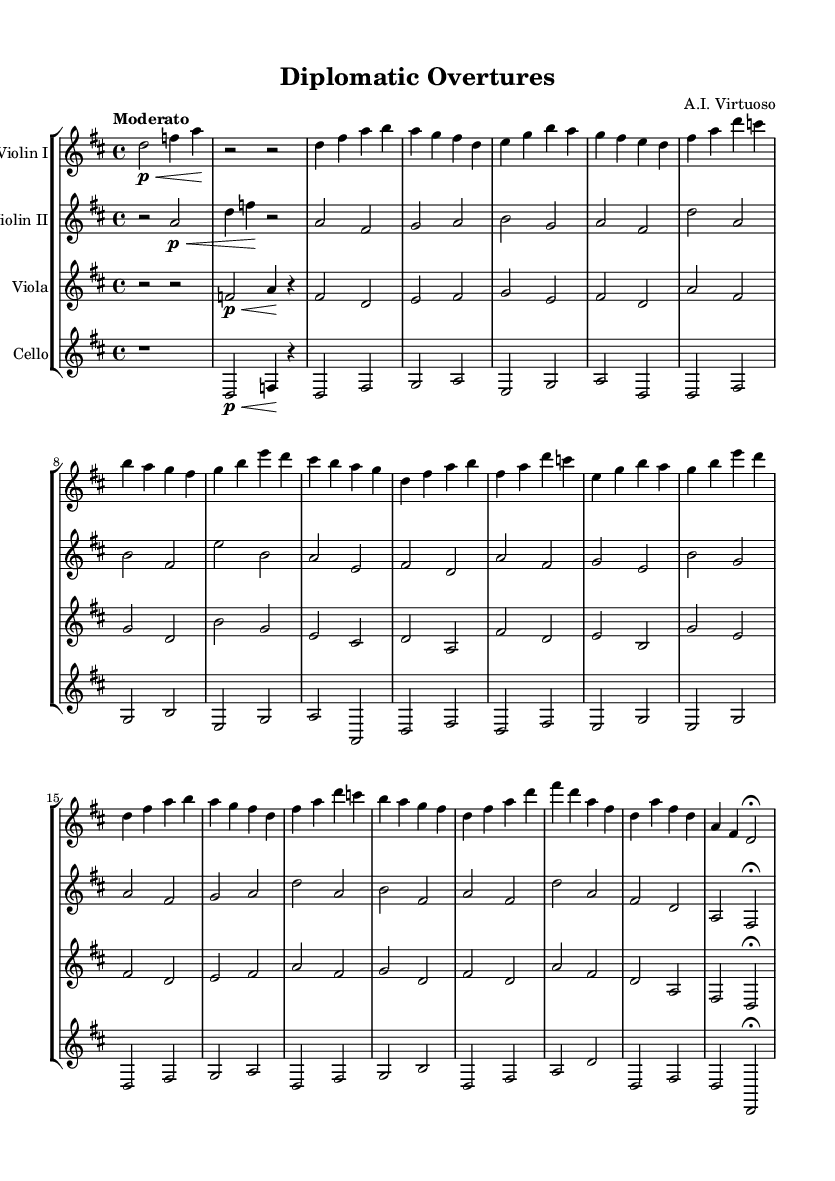What is the key signature of this music? The key signature shows two sharps, which indicates D major (or B minor). This can be identified in the left section of the staff, where the sharps appear before the notes.
Answer: D major What is the time signature of this piece? The time signature is found at the beginning of the music, indicated as a fraction of 4 over 4, meaning each measure contains four beats and the quarter note gets one beat.
Answer: 4/4 What is the tempo marking of this composition? The tempo marking is found in the text above the staff, indicating "Moderato," which suggests a moderate speed for the execution of the piece.
Answer: Moderato How many sections are in the music? By analyzing the structure, there are five distinct sections: Introduction, Theme A, Theme B, Development, and Coda. Each section has its own unique musical material.
Answer: Five What instruments are included in this chamber music quartet? The instruments are listed in the score, indicating the presence of two violins, one viola, and one cello. This combination is typical for a string quartet.
Answer: Two violins, one viola, one cello Which theme has a descending melodic pattern in this piece? By examining the melodic lines in both themes, Theme A shows a descending pattern when the notes move from high to low (e.g., starting from D and descending through A and G).
Answer: Theme A What type of musical form is predominantly used in this composition? The form follows the classical sonata structure, characterized by the exposition (Themes A and B), development, and recapitulation, which is commonly seen in Romantic compositions.
Answer: Sonata form 